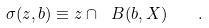<formula> <loc_0><loc_0><loc_500><loc_500>\sigma ( z , b ) \equiv z \cap \ B ( b , X ) \quad .</formula> 